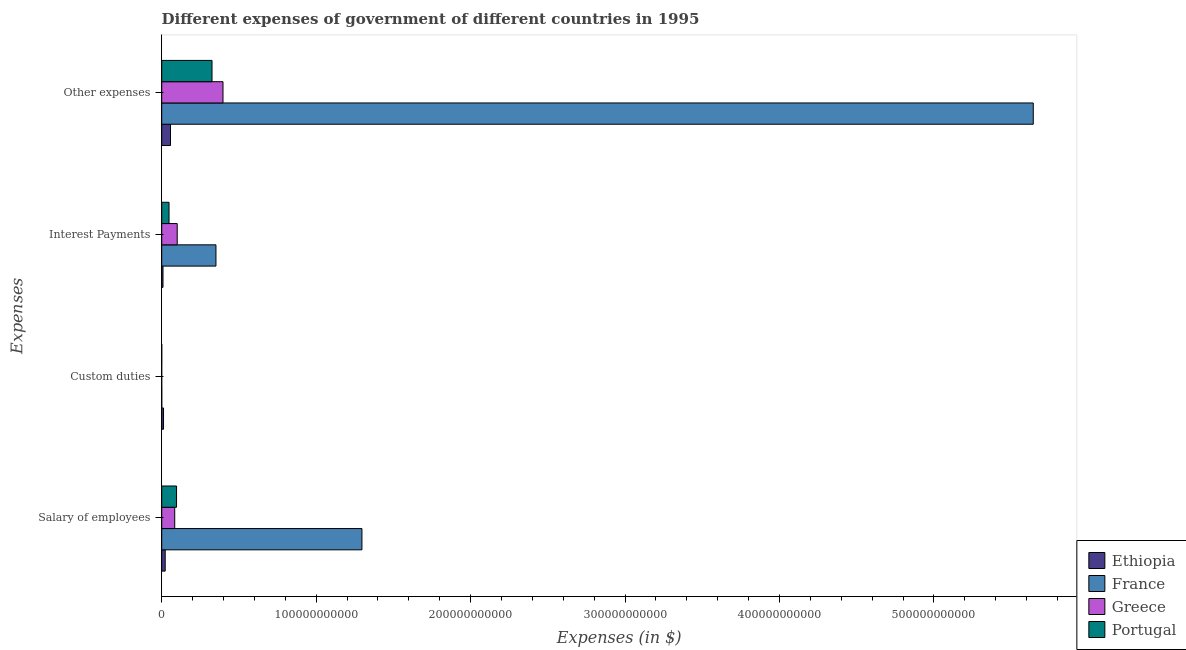How many different coloured bars are there?
Provide a succinct answer. 4. How many groups of bars are there?
Offer a very short reply. 4. Are the number of bars on each tick of the Y-axis equal?
Your response must be concise. No. How many bars are there on the 3rd tick from the bottom?
Make the answer very short. 4. What is the label of the 3rd group of bars from the top?
Provide a short and direct response. Custom duties. What is the amount spent on salary of employees in Greece?
Offer a terse response. 8.42e+09. Across all countries, what is the maximum amount spent on custom duties?
Your answer should be very brief. 1.18e+09. Across all countries, what is the minimum amount spent on interest payments?
Offer a very short reply. 8.39e+08. In which country was the amount spent on custom duties maximum?
Make the answer very short. Ethiopia. What is the total amount spent on interest payments in the graph?
Provide a short and direct response. 5.07e+1. What is the difference between the amount spent on interest payments in Ethiopia and that in Portugal?
Your response must be concise. -3.90e+09. What is the difference between the amount spent on salary of employees in Ethiopia and the amount spent on other expenses in Greece?
Your answer should be very brief. -3.74e+1. What is the average amount spent on salary of employees per country?
Make the answer very short. 3.75e+1. What is the difference between the amount spent on other expenses and amount spent on custom duties in Ethiopia?
Keep it short and to the point. 4.51e+09. What is the ratio of the amount spent on salary of employees in Ethiopia to that in Greece?
Provide a short and direct response. 0.27. Is the amount spent on interest payments in France less than that in Greece?
Keep it short and to the point. No. What is the difference between the highest and the second highest amount spent on custom duties?
Offer a terse response. 1.16e+09. What is the difference between the highest and the lowest amount spent on other expenses?
Your answer should be very brief. 5.59e+11. In how many countries, is the amount spent on interest payments greater than the average amount spent on interest payments taken over all countries?
Your answer should be compact. 1. Is it the case that in every country, the sum of the amount spent on other expenses and amount spent on custom duties is greater than the sum of amount spent on salary of employees and amount spent on interest payments?
Provide a succinct answer. No. Is it the case that in every country, the sum of the amount spent on salary of employees and amount spent on custom duties is greater than the amount spent on interest payments?
Your answer should be very brief. No. How many bars are there?
Offer a terse response. 15. Are all the bars in the graph horizontal?
Provide a succinct answer. Yes. How many countries are there in the graph?
Make the answer very short. 4. What is the difference between two consecutive major ticks on the X-axis?
Your answer should be compact. 1.00e+11. Are the values on the major ticks of X-axis written in scientific E-notation?
Keep it short and to the point. No. Does the graph contain grids?
Ensure brevity in your answer.  No. Where does the legend appear in the graph?
Keep it short and to the point. Bottom right. How many legend labels are there?
Ensure brevity in your answer.  4. What is the title of the graph?
Provide a succinct answer. Different expenses of government of different countries in 1995. Does "Monaco" appear as one of the legend labels in the graph?
Make the answer very short. No. What is the label or title of the X-axis?
Provide a succinct answer. Expenses (in $). What is the label or title of the Y-axis?
Give a very brief answer. Expenses. What is the Expenses (in $) of Ethiopia in Salary of employees?
Keep it short and to the point. 2.26e+09. What is the Expenses (in $) in France in Salary of employees?
Keep it short and to the point. 1.30e+11. What is the Expenses (in $) in Greece in Salary of employees?
Keep it short and to the point. 8.42e+09. What is the Expenses (in $) of Portugal in Salary of employees?
Make the answer very short. 9.61e+09. What is the Expenses (in $) in Ethiopia in Custom duties?
Provide a short and direct response. 1.18e+09. What is the Expenses (in $) of France in Custom duties?
Your response must be concise. 2.00e+07. What is the Expenses (in $) of Portugal in Custom duties?
Provide a succinct answer. 1.20e+06. What is the Expenses (in $) of Ethiopia in Interest Payments?
Your answer should be very brief. 8.39e+08. What is the Expenses (in $) of France in Interest Payments?
Ensure brevity in your answer.  3.51e+1. What is the Expenses (in $) in Greece in Interest Payments?
Your response must be concise. 1.00e+1. What is the Expenses (in $) of Portugal in Interest Payments?
Your response must be concise. 4.74e+09. What is the Expenses (in $) in Ethiopia in Other expenses?
Your response must be concise. 5.69e+09. What is the Expenses (in $) of France in Other expenses?
Your answer should be compact. 5.64e+11. What is the Expenses (in $) in Greece in Other expenses?
Provide a short and direct response. 3.97e+1. What is the Expenses (in $) of Portugal in Other expenses?
Your answer should be very brief. 3.26e+1. Across all Expenses, what is the maximum Expenses (in $) in Ethiopia?
Ensure brevity in your answer.  5.69e+09. Across all Expenses, what is the maximum Expenses (in $) of France?
Your answer should be very brief. 5.64e+11. Across all Expenses, what is the maximum Expenses (in $) in Greece?
Make the answer very short. 3.97e+1. Across all Expenses, what is the maximum Expenses (in $) in Portugal?
Your answer should be very brief. 3.26e+1. Across all Expenses, what is the minimum Expenses (in $) in Ethiopia?
Ensure brevity in your answer.  8.39e+08. Across all Expenses, what is the minimum Expenses (in $) in Portugal?
Your response must be concise. 1.20e+06. What is the total Expenses (in $) of Ethiopia in the graph?
Your answer should be compact. 9.96e+09. What is the total Expenses (in $) in France in the graph?
Provide a short and direct response. 7.29e+11. What is the total Expenses (in $) of Greece in the graph?
Provide a succinct answer. 5.81e+1. What is the total Expenses (in $) of Portugal in the graph?
Keep it short and to the point. 4.69e+1. What is the difference between the Expenses (in $) in Ethiopia in Salary of employees and that in Custom duties?
Provide a short and direct response. 1.08e+09. What is the difference between the Expenses (in $) of France in Salary of employees and that in Custom duties?
Keep it short and to the point. 1.30e+11. What is the difference between the Expenses (in $) of Portugal in Salary of employees and that in Custom duties?
Give a very brief answer. 9.61e+09. What is the difference between the Expenses (in $) in Ethiopia in Salary of employees and that in Interest Payments?
Make the answer very short. 1.42e+09. What is the difference between the Expenses (in $) of France in Salary of employees and that in Interest Payments?
Your response must be concise. 9.45e+1. What is the difference between the Expenses (in $) in Greece in Salary of employees and that in Interest Payments?
Make the answer very short. -1.61e+09. What is the difference between the Expenses (in $) in Portugal in Salary of employees and that in Interest Payments?
Your response must be concise. 4.87e+09. What is the difference between the Expenses (in $) of Ethiopia in Salary of employees and that in Other expenses?
Ensure brevity in your answer.  -3.43e+09. What is the difference between the Expenses (in $) of France in Salary of employees and that in Other expenses?
Provide a succinct answer. -4.35e+11. What is the difference between the Expenses (in $) in Greece in Salary of employees and that in Other expenses?
Your answer should be very brief. -3.13e+1. What is the difference between the Expenses (in $) of Portugal in Salary of employees and that in Other expenses?
Your answer should be compact. -2.30e+1. What is the difference between the Expenses (in $) of Ethiopia in Custom duties and that in Interest Payments?
Offer a very short reply. 3.41e+08. What is the difference between the Expenses (in $) of France in Custom duties and that in Interest Payments?
Give a very brief answer. -3.51e+1. What is the difference between the Expenses (in $) in Portugal in Custom duties and that in Interest Payments?
Your answer should be compact. -4.73e+09. What is the difference between the Expenses (in $) of Ethiopia in Custom duties and that in Other expenses?
Keep it short and to the point. -4.51e+09. What is the difference between the Expenses (in $) in France in Custom duties and that in Other expenses?
Offer a terse response. -5.64e+11. What is the difference between the Expenses (in $) of Portugal in Custom duties and that in Other expenses?
Provide a short and direct response. -3.26e+1. What is the difference between the Expenses (in $) in Ethiopia in Interest Payments and that in Other expenses?
Provide a short and direct response. -4.85e+09. What is the difference between the Expenses (in $) of France in Interest Payments and that in Other expenses?
Your answer should be very brief. -5.29e+11. What is the difference between the Expenses (in $) in Greece in Interest Payments and that in Other expenses?
Make the answer very short. -2.96e+1. What is the difference between the Expenses (in $) of Portugal in Interest Payments and that in Other expenses?
Offer a very short reply. -2.78e+1. What is the difference between the Expenses (in $) of Ethiopia in Salary of employees and the Expenses (in $) of France in Custom duties?
Your response must be concise. 2.24e+09. What is the difference between the Expenses (in $) of Ethiopia in Salary of employees and the Expenses (in $) of Portugal in Custom duties?
Your answer should be very brief. 2.26e+09. What is the difference between the Expenses (in $) in France in Salary of employees and the Expenses (in $) in Portugal in Custom duties?
Offer a very short reply. 1.30e+11. What is the difference between the Expenses (in $) of Greece in Salary of employees and the Expenses (in $) of Portugal in Custom duties?
Offer a terse response. 8.42e+09. What is the difference between the Expenses (in $) of Ethiopia in Salary of employees and the Expenses (in $) of France in Interest Payments?
Your answer should be very brief. -3.29e+1. What is the difference between the Expenses (in $) in Ethiopia in Salary of employees and the Expenses (in $) in Greece in Interest Payments?
Your answer should be very brief. -7.78e+09. What is the difference between the Expenses (in $) in Ethiopia in Salary of employees and the Expenses (in $) in Portugal in Interest Payments?
Offer a very short reply. -2.48e+09. What is the difference between the Expenses (in $) in France in Salary of employees and the Expenses (in $) in Greece in Interest Payments?
Your answer should be very brief. 1.20e+11. What is the difference between the Expenses (in $) of France in Salary of employees and the Expenses (in $) of Portugal in Interest Payments?
Make the answer very short. 1.25e+11. What is the difference between the Expenses (in $) in Greece in Salary of employees and the Expenses (in $) in Portugal in Interest Payments?
Your answer should be compact. 3.69e+09. What is the difference between the Expenses (in $) in Ethiopia in Salary of employees and the Expenses (in $) in France in Other expenses?
Your answer should be compact. -5.62e+11. What is the difference between the Expenses (in $) of Ethiopia in Salary of employees and the Expenses (in $) of Greece in Other expenses?
Your answer should be very brief. -3.74e+1. What is the difference between the Expenses (in $) in Ethiopia in Salary of employees and the Expenses (in $) in Portugal in Other expenses?
Provide a succinct answer. -3.03e+1. What is the difference between the Expenses (in $) in France in Salary of employees and the Expenses (in $) in Greece in Other expenses?
Your answer should be very brief. 9.00e+1. What is the difference between the Expenses (in $) of France in Salary of employees and the Expenses (in $) of Portugal in Other expenses?
Keep it short and to the point. 9.71e+1. What is the difference between the Expenses (in $) in Greece in Salary of employees and the Expenses (in $) in Portugal in Other expenses?
Provide a short and direct response. -2.41e+1. What is the difference between the Expenses (in $) in Ethiopia in Custom duties and the Expenses (in $) in France in Interest Payments?
Offer a very short reply. -3.39e+1. What is the difference between the Expenses (in $) of Ethiopia in Custom duties and the Expenses (in $) of Greece in Interest Payments?
Provide a short and direct response. -8.86e+09. What is the difference between the Expenses (in $) of Ethiopia in Custom duties and the Expenses (in $) of Portugal in Interest Payments?
Make the answer very short. -3.56e+09. What is the difference between the Expenses (in $) in France in Custom duties and the Expenses (in $) in Greece in Interest Payments?
Your answer should be compact. -1.00e+1. What is the difference between the Expenses (in $) in France in Custom duties and the Expenses (in $) in Portugal in Interest Payments?
Ensure brevity in your answer.  -4.72e+09. What is the difference between the Expenses (in $) of Ethiopia in Custom duties and the Expenses (in $) of France in Other expenses?
Provide a short and direct response. -5.63e+11. What is the difference between the Expenses (in $) of Ethiopia in Custom duties and the Expenses (in $) of Greece in Other expenses?
Give a very brief answer. -3.85e+1. What is the difference between the Expenses (in $) in Ethiopia in Custom duties and the Expenses (in $) in Portugal in Other expenses?
Ensure brevity in your answer.  -3.14e+1. What is the difference between the Expenses (in $) in France in Custom duties and the Expenses (in $) in Greece in Other expenses?
Make the answer very short. -3.97e+1. What is the difference between the Expenses (in $) of France in Custom duties and the Expenses (in $) of Portugal in Other expenses?
Offer a terse response. -3.26e+1. What is the difference between the Expenses (in $) of Ethiopia in Interest Payments and the Expenses (in $) of France in Other expenses?
Your answer should be compact. -5.63e+11. What is the difference between the Expenses (in $) in Ethiopia in Interest Payments and the Expenses (in $) in Greece in Other expenses?
Keep it short and to the point. -3.88e+1. What is the difference between the Expenses (in $) of Ethiopia in Interest Payments and the Expenses (in $) of Portugal in Other expenses?
Ensure brevity in your answer.  -3.17e+1. What is the difference between the Expenses (in $) in France in Interest Payments and the Expenses (in $) in Greece in Other expenses?
Your response must be concise. -4.56e+09. What is the difference between the Expenses (in $) in France in Interest Payments and the Expenses (in $) in Portugal in Other expenses?
Keep it short and to the point. 2.55e+09. What is the difference between the Expenses (in $) of Greece in Interest Payments and the Expenses (in $) of Portugal in Other expenses?
Offer a terse response. -2.25e+1. What is the average Expenses (in $) in Ethiopia per Expenses?
Keep it short and to the point. 2.49e+09. What is the average Expenses (in $) of France per Expenses?
Ensure brevity in your answer.  1.82e+11. What is the average Expenses (in $) in Greece per Expenses?
Provide a succinct answer. 1.45e+1. What is the average Expenses (in $) of Portugal per Expenses?
Make the answer very short. 1.17e+1. What is the difference between the Expenses (in $) of Ethiopia and Expenses (in $) of France in Salary of employees?
Offer a terse response. -1.27e+11. What is the difference between the Expenses (in $) in Ethiopia and Expenses (in $) in Greece in Salary of employees?
Your response must be concise. -6.17e+09. What is the difference between the Expenses (in $) of Ethiopia and Expenses (in $) of Portugal in Salary of employees?
Offer a terse response. -7.35e+09. What is the difference between the Expenses (in $) in France and Expenses (in $) in Greece in Salary of employees?
Provide a short and direct response. 1.21e+11. What is the difference between the Expenses (in $) of France and Expenses (in $) of Portugal in Salary of employees?
Provide a short and direct response. 1.20e+11. What is the difference between the Expenses (in $) of Greece and Expenses (in $) of Portugal in Salary of employees?
Give a very brief answer. -1.19e+09. What is the difference between the Expenses (in $) of Ethiopia and Expenses (in $) of France in Custom duties?
Offer a very short reply. 1.16e+09. What is the difference between the Expenses (in $) in Ethiopia and Expenses (in $) in Portugal in Custom duties?
Provide a short and direct response. 1.18e+09. What is the difference between the Expenses (in $) of France and Expenses (in $) of Portugal in Custom duties?
Offer a very short reply. 1.88e+07. What is the difference between the Expenses (in $) in Ethiopia and Expenses (in $) in France in Interest Payments?
Your response must be concise. -3.43e+1. What is the difference between the Expenses (in $) in Ethiopia and Expenses (in $) in Greece in Interest Payments?
Give a very brief answer. -9.20e+09. What is the difference between the Expenses (in $) in Ethiopia and Expenses (in $) in Portugal in Interest Payments?
Give a very brief answer. -3.90e+09. What is the difference between the Expenses (in $) in France and Expenses (in $) in Greece in Interest Payments?
Your response must be concise. 2.51e+1. What is the difference between the Expenses (in $) in France and Expenses (in $) in Portugal in Interest Payments?
Provide a succinct answer. 3.04e+1. What is the difference between the Expenses (in $) of Greece and Expenses (in $) of Portugal in Interest Payments?
Offer a very short reply. 5.30e+09. What is the difference between the Expenses (in $) of Ethiopia and Expenses (in $) of France in Other expenses?
Offer a terse response. -5.59e+11. What is the difference between the Expenses (in $) of Ethiopia and Expenses (in $) of Greece in Other expenses?
Keep it short and to the point. -3.40e+1. What is the difference between the Expenses (in $) of Ethiopia and Expenses (in $) of Portugal in Other expenses?
Give a very brief answer. -2.69e+1. What is the difference between the Expenses (in $) in France and Expenses (in $) in Greece in Other expenses?
Your response must be concise. 5.25e+11. What is the difference between the Expenses (in $) of France and Expenses (in $) of Portugal in Other expenses?
Your answer should be very brief. 5.32e+11. What is the difference between the Expenses (in $) of Greece and Expenses (in $) of Portugal in Other expenses?
Provide a short and direct response. 7.11e+09. What is the ratio of the Expenses (in $) in Ethiopia in Salary of employees to that in Custom duties?
Offer a terse response. 1.91. What is the ratio of the Expenses (in $) of France in Salary of employees to that in Custom duties?
Give a very brief answer. 6482. What is the ratio of the Expenses (in $) in Portugal in Salary of employees to that in Custom duties?
Keep it short and to the point. 8008.23. What is the ratio of the Expenses (in $) of Ethiopia in Salary of employees to that in Interest Payments?
Make the answer very short. 2.69. What is the ratio of the Expenses (in $) of France in Salary of employees to that in Interest Payments?
Offer a very short reply. 3.69. What is the ratio of the Expenses (in $) in Greece in Salary of employees to that in Interest Payments?
Your answer should be compact. 0.84. What is the ratio of the Expenses (in $) in Portugal in Salary of employees to that in Interest Payments?
Ensure brevity in your answer.  2.03. What is the ratio of the Expenses (in $) in Ethiopia in Salary of employees to that in Other expenses?
Ensure brevity in your answer.  0.4. What is the ratio of the Expenses (in $) in France in Salary of employees to that in Other expenses?
Offer a terse response. 0.23. What is the ratio of the Expenses (in $) in Greece in Salary of employees to that in Other expenses?
Your response must be concise. 0.21. What is the ratio of the Expenses (in $) in Portugal in Salary of employees to that in Other expenses?
Your answer should be compact. 0.29. What is the ratio of the Expenses (in $) of Ethiopia in Custom duties to that in Interest Payments?
Your answer should be very brief. 1.41. What is the ratio of the Expenses (in $) of France in Custom duties to that in Interest Payments?
Your answer should be compact. 0. What is the ratio of the Expenses (in $) in Ethiopia in Custom duties to that in Other expenses?
Provide a succinct answer. 0.21. What is the ratio of the Expenses (in $) in France in Custom duties to that in Other expenses?
Give a very brief answer. 0. What is the ratio of the Expenses (in $) of Ethiopia in Interest Payments to that in Other expenses?
Your answer should be very brief. 0.15. What is the ratio of the Expenses (in $) in France in Interest Payments to that in Other expenses?
Your answer should be very brief. 0.06. What is the ratio of the Expenses (in $) of Greece in Interest Payments to that in Other expenses?
Provide a succinct answer. 0.25. What is the ratio of the Expenses (in $) in Portugal in Interest Payments to that in Other expenses?
Your answer should be compact. 0.15. What is the difference between the highest and the second highest Expenses (in $) in Ethiopia?
Offer a very short reply. 3.43e+09. What is the difference between the highest and the second highest Expenses (in $) in France?
Provide a short and direct response. 4.35e+11. What is the difference between the highest and the second highest Expenses (in $) in Greece?
Offer a terse response. 2.96e+1. What is the difference between the highest and the second highest Expenses (in $) in Portugal?
Your answer should be very brief. 2.30e+1. What is the difference between the highest and the lowest Expenses (in $) in Ethiopia?
Give a very brief answer. 4.85e+09. What is the difference between the highest and the lowest Expenses (in $) of France?
Offer a very short reply. 5.64e+11. What is the difference between the highest and the lowest Expenses (in $) of Greece?
Give a very brief answer. 3.97e+1. What is the difference between the highest and the lowest Expenses (in $) of Portugal?
Offer a terse response. 3.26e+1. 